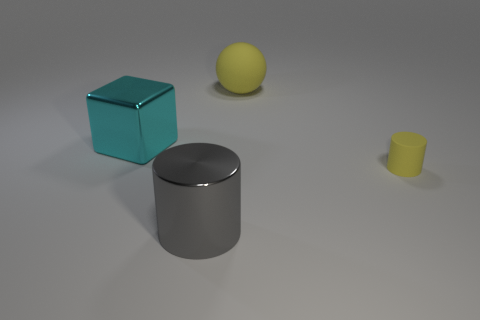Is the shape of the metallic object that is left of the gray thing the same as the large object right of the metal cylinder?
Give a very brief answer. No. What shape is the large matte thing that is the same color as the small matte thing?
Ensure brevity in your answer.  Sphere. Is there another yellow cylinder that has the same material as the large cylinder?
Your answer should be compact. No. What number of rubber things are large cyan blocks or yellow balls?
Your answer should be very brief. 1. What shape is the big metallic object that is behind the cylinder that is to the left of the big yellow sphere?
Provide a succinct answer. Cube. Is the number of large cylinders that are to the right of the large matte object less than the number of small cyan cylinders?
Your answer should be very brief. No. The gray thing has what shape?
Offer a very short reply. Cylinder. There is a object on the left side of the large gray shiny thing; what is its size?
Your answer should be very brief. Large. There is a metal thing that is the same size as the cyan cube; what is its color?
Provide a short and direct response. Gray. Is there a big rubber ball of the same color as the metal cylinder?
Give a very brief answer. No. 